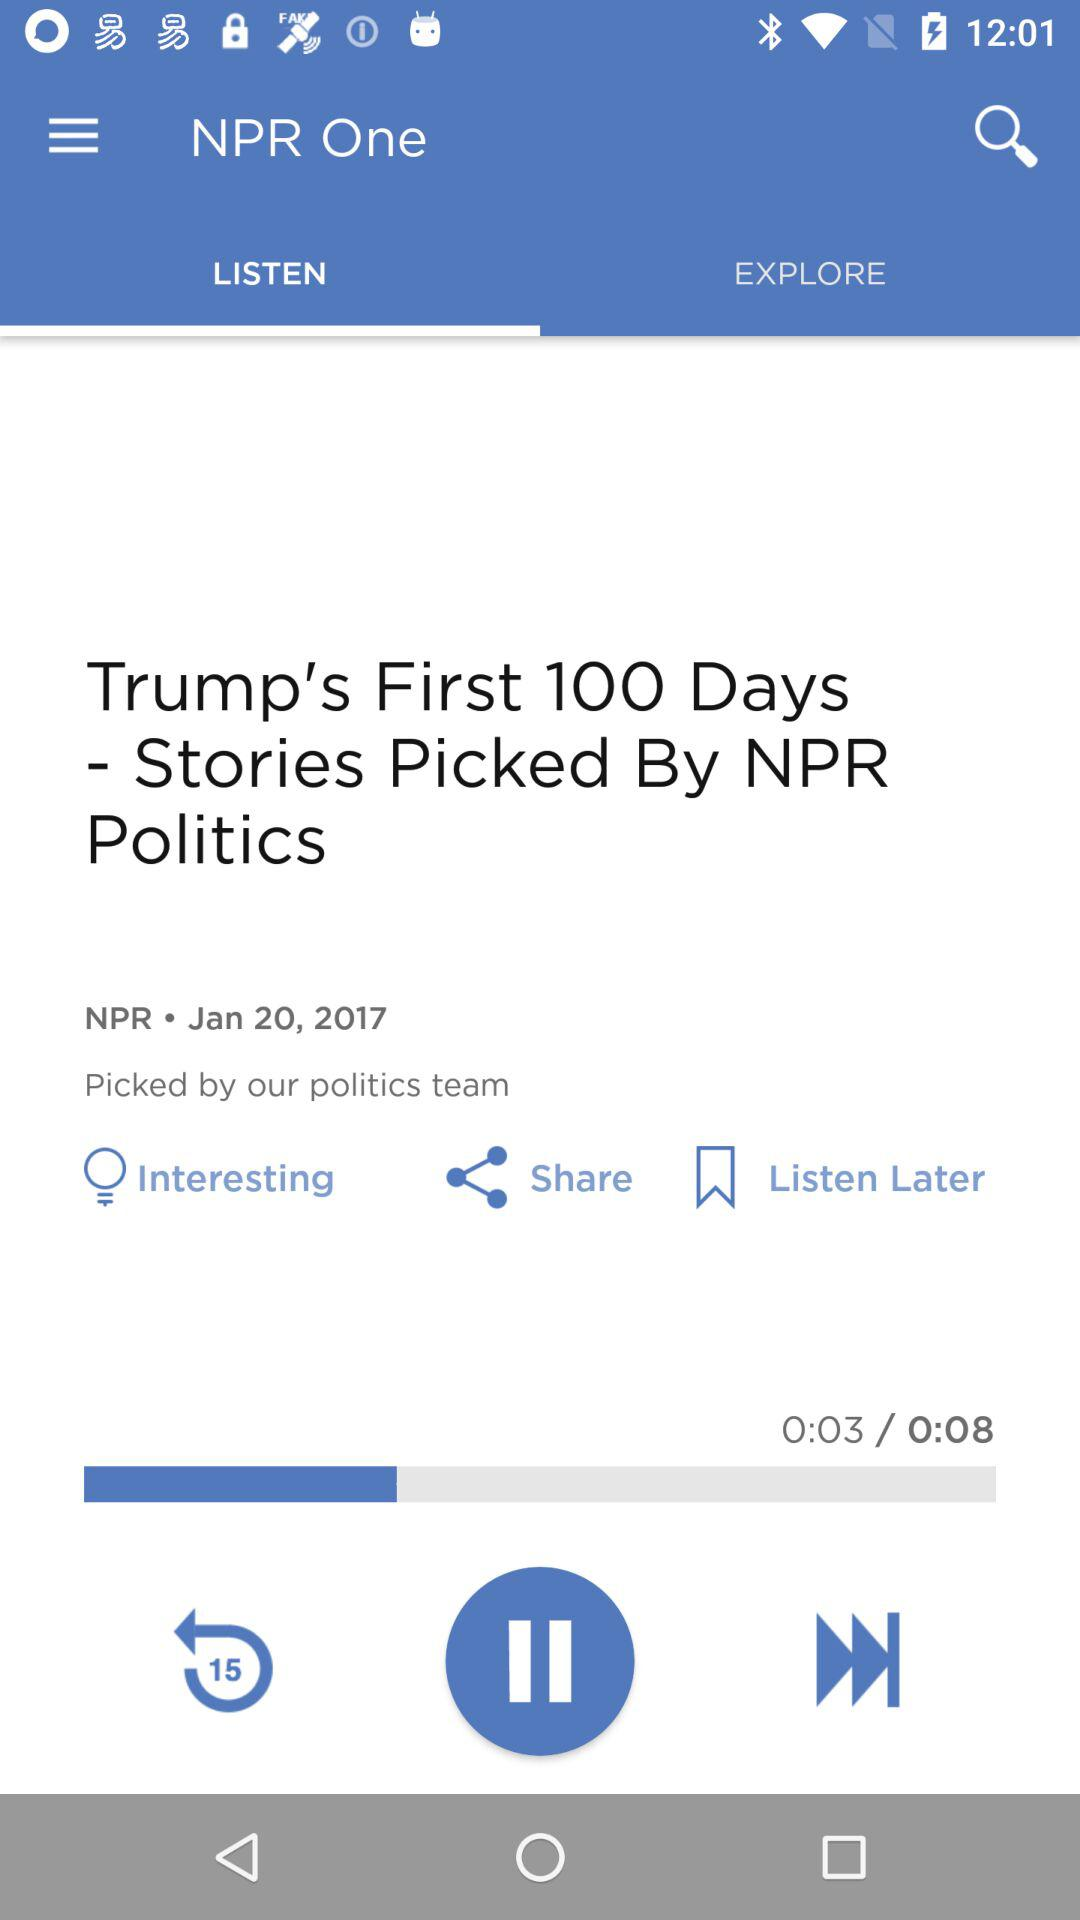Who picked Trump's first 100 days' stories? The one that picked Trump's 100 days' stories is "NPR Politics". 